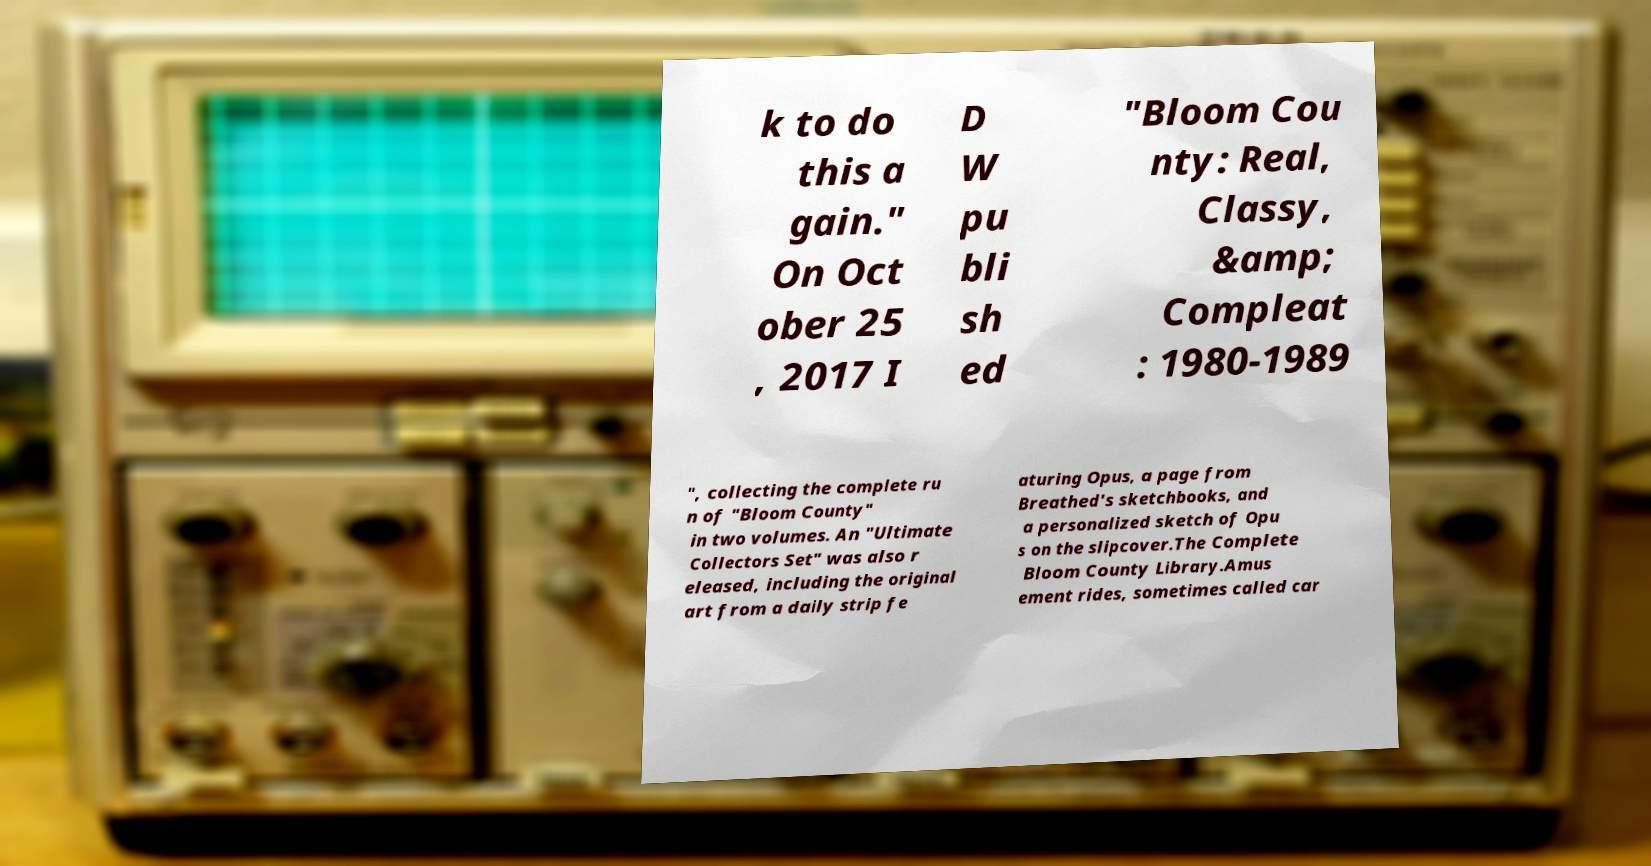Can you read and provide the text displayed in the image?This photo seems to have some interesting text. Can you extract and type it out for me? k to do this a gain." On Oct ober 25 , 2017 I D W pu bli sh ed "Bloom Cou nty: Real, Classy, &amp; Compleat : 1980-1989 ", collecting the complete ru n of "Bloom County" in two volumes. An "Ultimate Collectors Set" was also r eleased, including the original art from a daily strip fe aturing Opus, a page from Breathed's sketchbooks, and a personalized sketch of Opu s on the slipcover.The Complete Bloom County Library.Amus ement rides, sometimes called car 